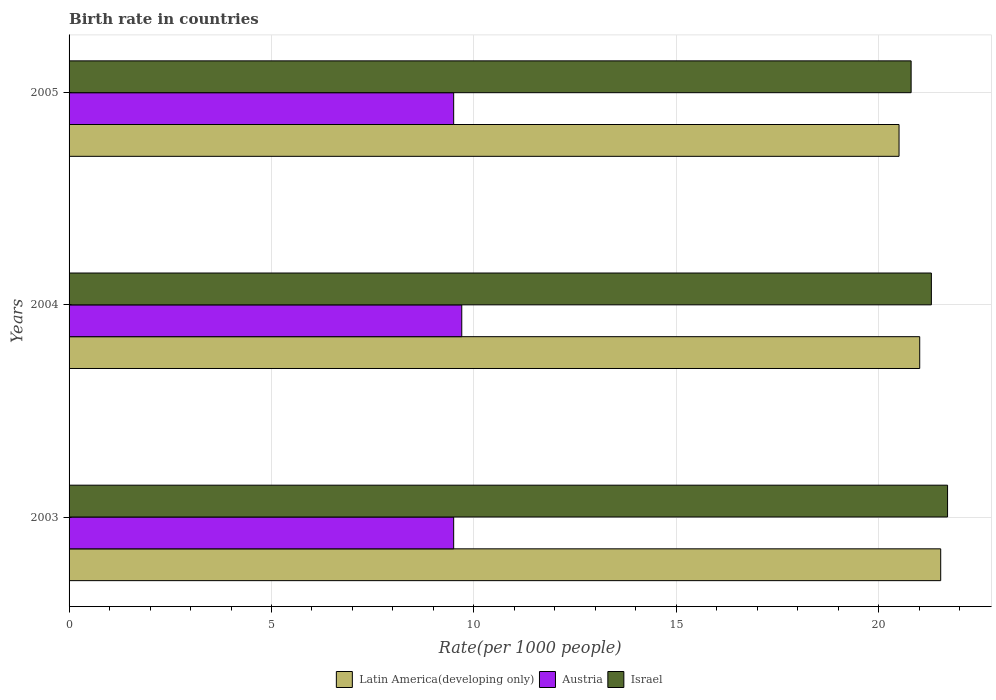How many different coloured bars are there?
Your answer should be very brief. 3. Are the number of bars on each tick of the Y-axis equal?
Your answer should be very brief. Yes. How many bars are there on the 2nd tick from the top?
Keep it short and to the point. 3. What is the label of the 2nd group of bars from the top?
Keep it short and to the point. 2004. In how many cases, is the number of bars for a given year not equal to the number of legend labels?
Your response must be concise. 0. What is the birth rate in Israel in 2005?
Ensure brevity in your answer.  20.8. Across all years, what is the maximum birth rate in Latin America(developing only)?
Your response must be concise. 21.53. Across all years, what is the minimum birth rate in Israel?
Offer a terse response. 20.8. What is the total birth rate in Austria in the graph?
Offer a terse response. 28.7. What is the difference between the birth rate in Latin America(developing only) in 2003 and that in 2004?
Your response must be concise. 0.52. What is the difference between the birth rate in Austria in 2004 and the birth rate in Latin America(developing only) in 2005?
Make the answer very short. -10.8. What is the average birth rate in Latin America(developing only) per year?
Ensure brevity in your answer.  21.01. In the year 2004, what is the difference between the birth rate in Israel and birth rate in Latin America(developing only)?
Your response must be concise. 0.29. In how many years, is the birth rate in Latin America(developing only) greater than 9 ?
Ensure brevity in your answer.  3. What is the ratio of the birth rate in Israel in 2004 to that in 2005?
Give a very brief answer. 1.02. Is the birth rate in Israel in 2003 less than that in 2004?
Give a very brief answer. No. What is the difference between the highest and the second highest birth rate in Latin America(developing only)?
Offer a terse response. 0.52. What is the difference between the highest and the lowest birth rate in Israel?
Make the answer very short. 0.9. Is the sum of the birth rate in Latin America(developing only) in 2003 and 2005 greater than the maximum birth rate in Israel across all years?
Give a very brief answer. Yes. What does the 1st bar from the bottom in 2004 represents?
Ensure brevity in your answer.  Latin America(developing only). How many bars are there?
Keep it short and to the point. 9. Are all the bars in the graph horizontal?
Give a very brief answer. Yes. What is the difference between two consecutive major ticks on the X-axis?
Your response must be concise. 5. Does the graph contain grids?
Offer a very short reply. Yes. What is the title of the graph?
Your answer should be very brief. Birth rate in countries. Does "Sierra Leone" appear as one of the legend labels in the graph?
Provide a short and direct response. No. What is the label or title of the X-axis?
Provide a short and direct response. Rate(per 1000 people). What is the label or title of the Y-axis?
Give a very brief answer. Years. What is the Rate(per 1000 people) in Latin America(developing only) in 2003?
Your response must be concise. 21.53. What is the Rate(per 1000 people) of Austria in 2003?
Ensure brevity in your answer.  9.5. What is the Rate(per 1000 people) in Israel in 2003?
Your answer should be very brief. 21.7. What is the Rate(per 1000 people) of Latin America(developing only) in 2004?
Keep it short and to the point. 21.01. What is the Rate(per 1000 people) in Israel in 2004?
Ensure brevity in your answer.  21.3. What is the Rate(per 1000 people) of Latin America(developing only) in 2005?
Make the answer very short. 20.5. What is the Rate(per 1000 people) in Austria in 2005?
Make the answer very short. 9.5. What is the Rate(per 1000 people) in Israel in 2005?
Provide a succinct answer. 20.8. Across all years, what is the maximum Rate(per 1000 people) in Latin America(developing only)?
Give a very brief answer. 21.53. Across all years, what is the maximum Rate(per 1000 people) of Austria?
Make the answer very short. 9.7. Across all years, what is the maximum Rate(per 1000 people) in Israel?
Your response must be concise. 21.7. Across all years, what is the minimum Rate(per 1000 people) in Latin America(developing only)?
Keep it short and to the point. 20.5. Across all years, what is the minimum Rate(per 1000 people) of Austria?
Your answer should be very brief. 9.5. Across all years, what is the minimum Rate(per 1000 people) in Israel?
Give a very brief answer. 20.8. What is the total Rate(per 1000 people) of Latin America(developing only) in the graph?
Ensure brevity in your answer.  63.04. What is the total Rate(per 1000 people) in Austria in the graph?
Provide a short and direct response. 28.7. What is the total Rate(per 1000 people) of Israel in the graph?
Provide a short and direct response. 63.8. What is the difference between the Rate(per 1000 people) in Latin America(developing only) in 2003 and that in 2004?
Provide a succinct answer. 0.52. What is the difference between the Rate(per 1000 people) of Austria in 2003 and that in 2004?
Ensure brevity in your answer.  -0.2. What is the difference between the Rate(per 1000 people) of Israel in 2003 and that in 2004?
Ensure brevity in your answer.  0.4. What is the difference between the Rate(per 1000 people) of Latin America(developing only) in 2003 and that in 2005?
Your response must be concise. 1.03. What is the difference between the Rate(per 1000 people) in Latin America(developing only) in 2004 and that in 2005?
Keep it short and to the point. 0.51. What is the difference between the Rate(per 1000 people) in Austria in 2004 and that in 2005?
Your answer should be very brief. 0.2. What is the difference between the Rate(per 1000 people) in Latin America(developing only) in 2003 and the Rate(per 1000 people) in Austria in 2004?
Offer a terse response. 11.83. What is the difference between the Rate(per 1000 people) of Latin America(developing only) in 2003 and the Rate(per 1000 people) of Israel in 2004?
Your answer should be compact. 0.23. What is the difference between the Rate(per 1000 people) in Latin America(developing only) in 2003 and the Rate(per 1000 people) in Austria in 2005?
Ensure brevity in your answer.  12.03. What is the difference between the Rate(per 1000 people) in Latin America(developing only) in 2003 and the Rate(per 1000 people) in Israel in 2005?
Ensure brevity in your answer.  0.73. What is the difference between the Rate(per 1000 people) in Austria in 2003 and the Rate(per 1000 people) in Israel in 2005?
Keep it short and to the point. -11.3. What is the difference between the Rate(per 1000 people) in Latin America(developing only) in 2004 and the Rate(per 1000 people) in Austria in 2005?
Provide a succinct answer. 11.51. What is the difference between the Rate(per 1000 people) in Latin America(developing only) in 2004 and the Rate(per 1000 people) in Israel in 2005?
Ensure brevity in your answer.  0.21. What is the average Rate(per 1000 people) of Latin America(developing only) per year?
Your answer should be very brief. 21.01. What is the average Rate(per 1000 people) of Austria per year?
Keep it short and to the point. 9.57. What is the average Rate(per 1000 people) in Israel per year?
Your response must be concise. 21.27. In the year 2003, what is the difference between the Rate(per 1000 people) of Latin America(developing only) and Rate(per 1000 people) of Austria?
Offer a terse response. 12.03. In the year 2003, what is the difference between the Rate(per 1000 people) in Latin America(developing only) and Rate(per 1000 people) in Israel?
Your response must be concise. -0.17. In the year 2003, what is the difference between the Rate(per 1000 people) of Austria and Rate(per 1000 people) of Israel?
Your response must be concise. -12.2. In the year 2004, what is the difference between the Rate(per 1000 people) in Latin America(developing only) and Rate(per 1000 people) in Austria?
Your answer should be compact. 11.31. In the year 2004, what is the difference between the Rate(per 1000 people) in Latin America(developing only) and Rate(per 1000 people) in Israel?
Ensure brevity in your answer.  -0.29. In the year 2004, what is the difference between the Rate(per 1000 people) in Austria and Rate(per 1000 people) in Israel?
Make the answer very short. -11.6. In the year 2005, what is the difference between the Rate(per 1000 people) in Latin America(developing only) and Rate(per 1000 people) in Austria?
Offer a very short reply. 11. In the year 2005, what is the difference between the Rate(per 1000 people) in Latin America(developing only) and Rate(per 1000 people) in Israel?
Provide a succinct answer. -0.3. In the year 2005, what is the difference between the Rate(per 1000 people) of Austria and Rate(per 1000 people) of Israel?
Provide a succinct answer. -11.3. What is the ratio of the Rate(per 1000 people) of Latin America(developing only) in 2003 to that in 2004?
Keep it short and to the point. 1.02. What is the ratio of the Rate(per 1000 people) in Austria in 2003 to that in 2004?
Your answer should be very brief. 0.98. What is the ratio of the Rate(per 1000 people) in Israel in 2003 to that in 2004?
Provide a short and direct response. 1.02. What is the ratio of the Rate(per 1000 people) of Latin America(developing only) in 2003 to that in 2005?
Make the answer very short. 1.05. What is the ratio of the Rate(per 1000 people) of Austria in 2003 to that in 2005?
Give a very brief answer. 1. What is the ratio of the Rate(per 1000 people) of Israel in 2003 to that in 2005?
Provide a succinct answer. 1.04. What is the ratio of the Rate(per 1000 people) in Latin America(developing only) in 2004 to that in 2005?
Offer a very short reply. 1.02. What is the ratio of the Rate(per 1000 people) of Austria in 2004 to that in 2005?
Offer a terse response. 1.02. What is the ratio of the Rate(per 1000 people) in Israel in 2004 to that in 2005?
Give a very brief answer. 1.02. What is the difference between the highest and the second highest Rate(per 1000 people) of Latin America(developing only)?
Provide a short and direct response. 0.52. What is the difference between the highest and the second highest Rate(per 1000 people) of Austria?
Offer a terse response. 0.2. What is the difference between the highest and the second highest Rate(per 1000 people) of Israel?
Make the answer very short. 0.4. What is the difference between the highest and the lowest Rate(per 1000 people) in Latin America(developing only)?
Ensure brevity in your answer.  1.03. What is the difference between the highest and the lowest Rate(per 1000 people) in Israel?
Make the answer very short. 0.9. 